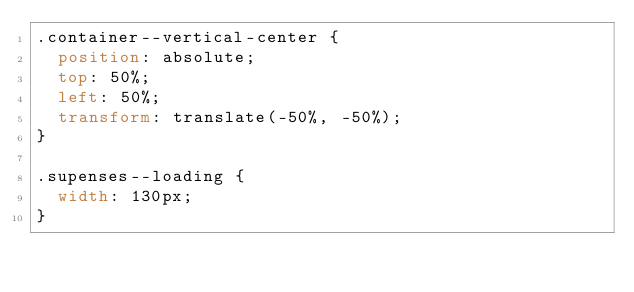Convert code to text. <code><loc_0><loc_0><loc_500><loc_500><_CSS_>.container--vertical-center {
  position: absolute;
  top: 50%;
  left: 50%;
  transform: translate(-50%, -50%);
}

.supenses--loading {
  width: 130px;
}
</code> 